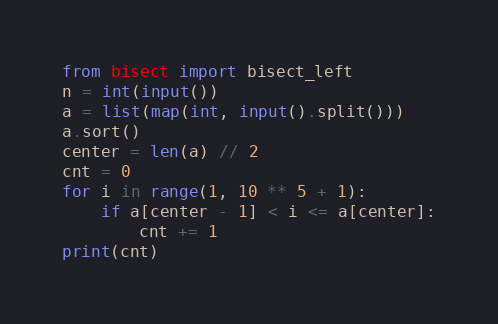<code> <loc_0><loc_0><loc_500><loc_500><_Python_>from bisect import bisect_left
n = int(input())
a = list(map(int, input().split()))
a.sort()
center = len(a) // 2
cnt = 0
for i in range(1, 10 ** 5 + 1):
    if a[center - 1] < i <= a[center]:
        cnt += 1
print(cnt)
</code> 